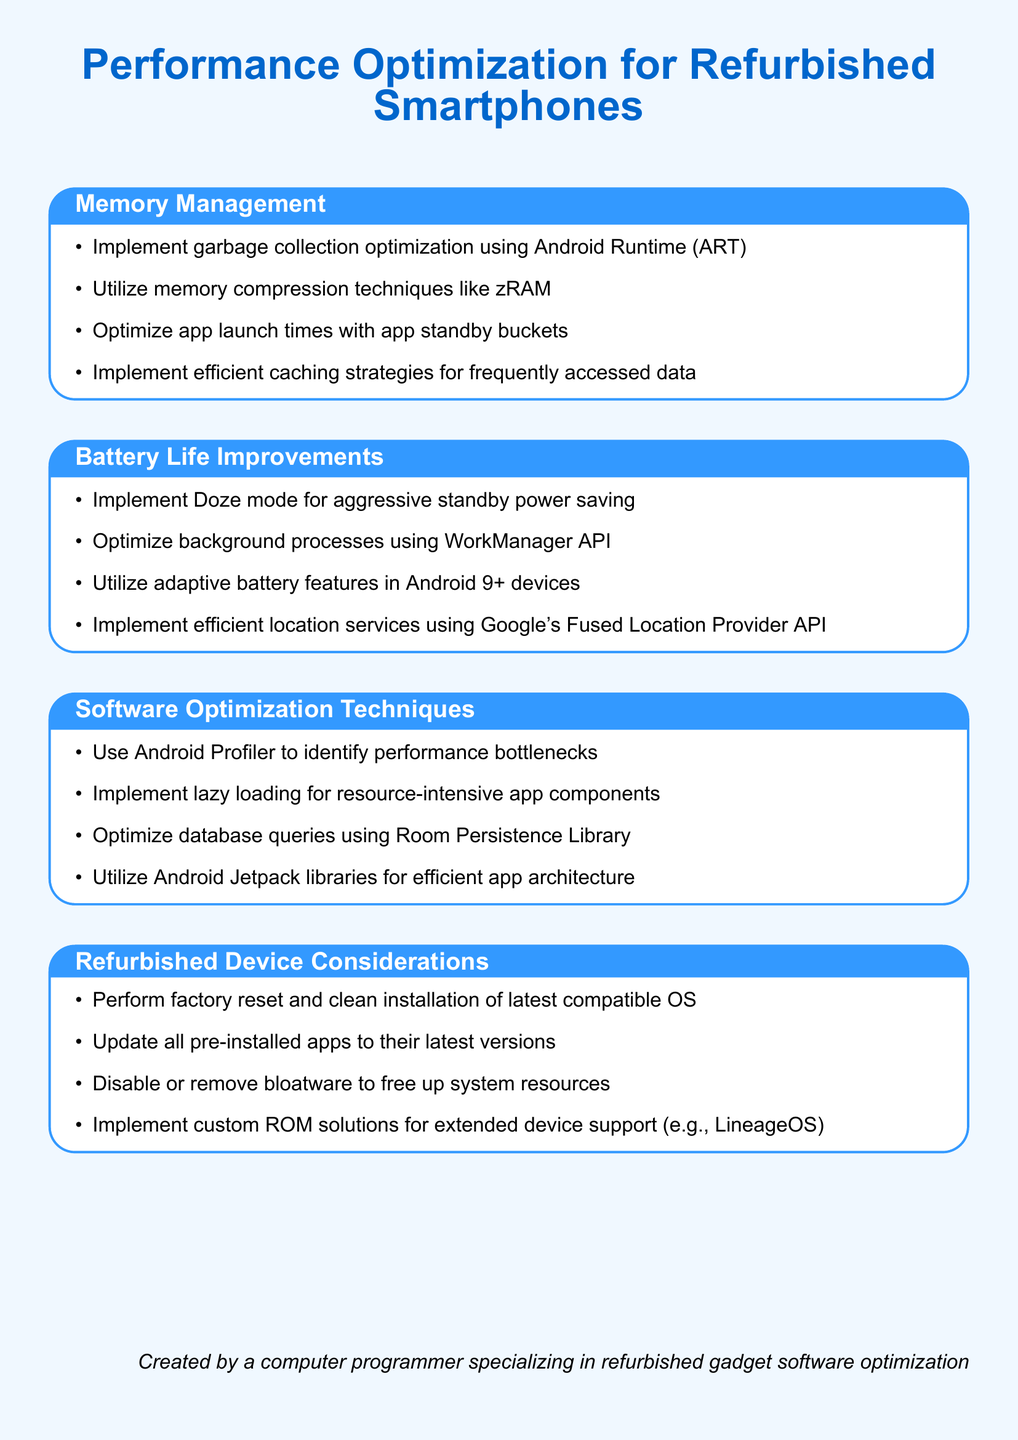What is the title of the document? The title of the document is given at the beginning, stating the main topic covered in the notes.
Answer: Performance Optimization for Refurbished Smartphones How many sections are in the document? There are multiple sections listed, each covering different aspects of performance optimization for refurbished smartphones.
Answer: Four What technique is suggested for optimizing app launch times? The point addresses the way to improve how quickly apps start, specifically highlighting a method for better performance.
Answer: App standby buckets What mode is recommended for aggressive standby power saving? This recommendation is found under battery life improvements, aimed at enhancing power conservation when the device is not in use.
Answer: Doze mode Which API is suggested for optimizing background processes? The document specifies a particular API that is effective in managing processes that run in the background, contributing to overall efficiency.
Answer: WorkManager API What library is recommended for optimizing database queries? This suggestion in the software optimization section addresses improving how data is accessed and manipulated in an application.
Answer: Room Persistence Library What is a suggested action for refurbishing a device's software? This point concerns a fundamental step in preparing a refurbished device for optimal performance and readiness for the user.
Answer: Factory reset Which feature is mentioned for devices running Android 9 or newer? This feature mentioned in battery life improvements caters specifically to recent Android versions to enhance power management.
Answer: Adaptive battery features What is advised for dealing with pre-installed applications? The document includes a recommendation for managing unnecessary software that comes with the device to improve system efficiency.
Answer: Disable or remove bloatware 